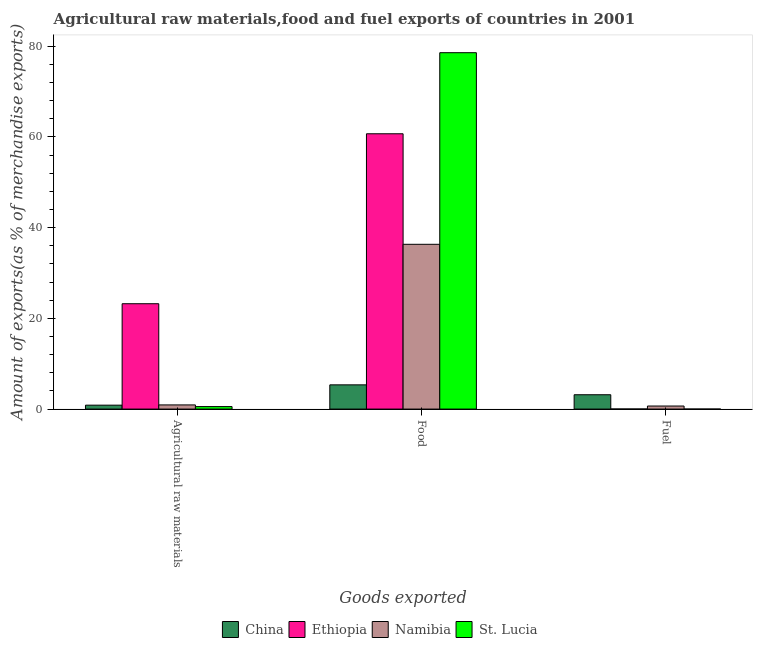How many different coloured bars are there?
Keep it short and to the point. 4. How many groups of bars are there?
Give a very brief answer. 3. Are the number of bars per tick equal to the number of legend labels?
Ensure brevity in your answer.  Yes. What is the label of the 3rd group of bars from the left?
Your answer should be very brief. Fuel. What is the percentage of raw materials exports in Ethiopia?
Provide a short and direct response. 23.22. Across all countries, what is the maximum percentage of fuel exports?
Keep it short and to the point. 3.16. Across all countries, what is the minimum percentage of fuel exports?
Offer a terse response. 0. In which country was the percentage of food exports maximum?
Offer a very short reply. St. Lucia. In which country was the percentage of raw materials exports minimum?
Your response must be concise. St. Lucia. What is the total percentage of fuel exports in the graph?
Keep it short and to the point. 3.85. What is the difference between the percentage of raw materials exports in Namibia and that in St. Lucia?
Your answer should be compact. 0.37. What is the difference between the percentage of raw materials exports in Ethiopia and the percentage of food exports in China?
Your response must be concise. 17.88. What is the average percentage of fuel exports per country?
Provide a short and direct response. 0.96. What is the difference between the percentage of food exports and percentage of fuel exports in Namibia?
Ensure brevity in your answer.  35.64. What is the ratio of the percentage of fuel exports in China to that in Namibia?
Provide a short and direct response. 4.68. Is the percentage of raw materials exports in St. Lucia less than that in Namibia?
Provide a short and direct response. Yes. What is the difference between the highest and the second highest percentage of raw materials exports?
Provide a succinct answer. 22.3. What is the difference between the highest and the lowest percentage of food exports?
Offer a terse response. 73.21. In how many countries, is the percentage of raw materials exports greater than the average percentage of raw materials exports taken over all countries?
Make the answer very short. 1. Is the sum of the percentage of fuel exports in Ethiopia and St. Lucia greater than the maximum percentage of raw materials exports across all countries?
Your answer should be very brief. No. What does the 3rd bar from the left in Agricultural raw materials represents?
Ensure brevity in your answer.  Namibia. What does the 1st bar from the right in Fuel represents?
Offer a terse response. St. Lucia. Is it the case that in every country, the sum of the percentage of raw materials exports and percentage of food exports is greater than the percentage of fuel exports?
Your answer should be compact. Yes. How many bars are there?
Keep it short and to the point. 12. Are the values on the major ticks of Y-axis written in scientific E-notation?
Your answer should be compact. No. Does the graph contain grids?
Provide a succinct answer. No. Where does the legend appear in the graph?
Keep it short and to the point. Bottom center. What is the title of the graph?
Give a very brief answer. Agricultural raw materials,food and fuel exports of countries in 2001. Does "Nepal" appear as one of the legend labels in the graph?
Provide a short and direct response. No. What is the label or title of the X-axis?
Your answer should be compact. Goods exported. What is the label or title of the Y-axis?
Your answer should be very brief. Amount of exports(as % of merchandise exports). What is the Amount of exports(as % of merchandise exports) in China in Agricultural raw materials?
Offer a very short reply. 0.86. What is the Amount of exports(as % of merchandise exports) in Ethiopia in Agricultural raw materials?
Offer a very short reply. 23.22. What is the Amount of exports(as % of merchandise exports) in Namibia in Agricultural raw materials?
Your answer should be very brief. 0.92. What is the Amount of exports(as % of merchandise exports) of St. Lucia in Agricultural raw materials?
Your response must be concise. 0.55. What is the Amount of exports(as % of merchandise exports) in China in Food?
Your answer should be compact. 5.34. What is the Amount of exports(as % of merchandise exports) of Ethiopia in Food?
Keep it short and to the point. 60.68. What is the Amount of exports(as % of merchandise exports) of Namibia in Food?
Give a very brief answer. 36.32. What is the Amount of exports(as % of merchandise exports) in St. Lucia in Food?
Provide a short and direct response. 78.55. What is the Amount of exports(as % of merchandise exports) of China in Fuel?
Ensure brevity in your answer.  3.16. What is the Amount of exports(as % of merchandise exports) in Ethiopia in Fuel?
Provide a succinct answer. 0.01. What is the Amount of exports(as % of merchandise exports) of Namibia in Fuel?
Offer a terse response. 0.67. What is the Amount of exports(as % of merchandise exports) of St. Lucia in Fuel?
Make the answer very short. 0. Across all Goods exported, what is the maximum Amount of exports(as % of merchandise exports) of China?
Provide a short and direct response. 5.34. Across all Goods exported, what is the maximum Amount of exports(as % of merchandise exports) of Ethiopia?
Make the answer very short. 60.68. Across all Goods exported, what is the maximum Amount of exports(as % of merchandise exports) of Namibia?
Provide a succinct answer. 36.32. Across all Goods exported, what is the maximum Amount of exports(as % of merchandise exports) of St. Lucia?
Provide a succinct answer. 78.55. Across all Goods exported, what is the minimum Amount of exports(as % of merchandise exports) in China?
Make the answer very short. 0.86. Across all Goods exported, what is the minimum Amount of exports(as % of merchandise exports) of Ethiopia?
Your response must be concise. 0.01. Across all Goods exported, what is the minimum Amount of exports(as % of merchandise exports) of Namibia?
Offer a terse response. 0.67. Across all Goods exported, what is the minimum Amount of exports(as % of merchandise exports) in St. Lucia?
Offer a terse response. 0. What is the total Amount of exports(as % of merchandise exports) in China in the graph?
Keep it short and to the point. 9.36. What is the total Amount of exports(as % of merchandise exports) in Ethiopia in the graph?
Ensure brevity in your answer.  83.91. What is the total Amount of exports(as % of merchandise exports) of Namibia in the graph?
Your answer should be very brief. 37.91. What is the total Amount of exports(as % of merchandise exports) in St. Lucia in the graph?
Offer a very short reply. 79.1. What is the difference between the Amount of exports(as % of merchandise exports) in China in Agricultural raw materials and that in Food?
Your answer should be very brief. -4.48. What is the difference between the Amount of exports(as % of merchandise exports) in Ethiopia in Agricultural raw materials and that in Food?
Your answer should be compact. -37.46. What is the difference between the Amount of exports(as % of merchandise exports) of Namibia in Agricultural raw materials and that in Food?
Provide a succinct answer. -35.4. What is the difference between the Amount of exports(as % of merchandise exports) of St. Lucia in Agricultural raw materials and that in Food?
Provide a succinct answer. -78. What is the difference between the Amount of exports(as % of merchandise exports) of China in Agricultural raw materials and that in Fuel?
Make the answer very short. -2.29. What is the difference between the Amount of exports(as % of merchandise exports) of Ethiopia in Agricultural raw materials and that in Fuel?
Ensure brevity in your answer.  23.2. What is the difference between the Amount of exports(as % of merchandise exports) in Namibia in Agricultural raw materials and that in Fuel?
Ensure brevity in your answer.  0.24. What is the difference between the Amount of exports(as % of merchandise exports) of St. Lucia in Agricultural raw materials and that in Fuel?
Give a very brief answer. 0.55. What is the difference between the Amount of exports(as % of merchandise exports) in China in Food and that in Fuel?
Offer a terse response. 2.18. What is the difference between the Amount of exports(as % of merchandise exports) of Ethiopia in Food and that in Fuel?
Provide a succinct answer. 60.67. What is the difference between the Amount of exports(as % of merchandise exports) of Namibia in Food and that in Fuel?
Your answer should be very brief. 35.64. What is the difference between the Amount of exports(as % of merchandise exports) in St. Lucia in Food and that in Fuel?
Offer a very short reply. 78.55. What is the difference between the Amount of exports(as % of merchandise exports) in China in Agricultural raw materials and the Amount of exports(as % of merchandise exports) in Ethiopia in Food?
Your response must be concise. -59.82. What is the difference between the Amount of exports(as % of merchandise exports) in China in Agricultural raw materials and the Amount of exports(as % of merchandise exports) in Namibia in Food?
Your response must be concise. -35.45. What is the difference between the Amount of exports(as % of merchandise exports) in China in Agricultural raw materials and the Amount of exports(as % of merchandise exports) in St. Lucia in Food?
Provide a short and direct response. -77.69. What is the difference between the Amount of exports(as % of merchandise exports) of Ethiopia in Agricultural raw materials and the Amount of exports(as % of merchandise exports) of Namibia in Food?
Ensure brevity in your answer.  -13.1. What is the difference between the Amount of exports(as % of merchandise exports) of Ethiopia in Agricultural raw materials and the Amount of exports(as % of merchandise exports) of St. Lucia in Food?
Give a very brief answer. -55.33. What is the difference between the Amount of exports(as % of merchandise exports) in Namibia in Agricultural raw materials and the Amount of exports(as % of merchandise exports) in St. Lucia in Food?
Your response must be concise. -77.63. What is the difference between the Amount of exports(as % of merchandise exports) of China in Agricultural raw materials and the Amount of exports(as % of merchandise exports) of Ethiopia in Fuel?
Ensure brevity in your answer.  0.85. What is the difference between the Amount of exports(as % of merchandise exports) in China in Agricultural raw materials and the Amount of exports(as % of merchandise exports) in Namibia in Fuel?
Make the answer very short. 0.19. What is the difference between the Amount of exports(as % of merchandise exports) of China in Agricultural raw materials and the Amount of exports(as % of merchandise exports) of St. Lucia in Fuel?
Provide a short and direct response. 0.86. What is the difference between the Amount of exports(as % of merchandise exports) in Ethiopia in Agricultural raw materials and the Amount of exports(as % of merchandise exports) in Namibia in Fuel?
Make the answer very short. 22.54. What is the difference between the Amount of exports(as % of merchandise exports) of Ethiopia in Agricultural raw materials and the Amount of exports(as % of merchandise exports) of St. Lucia in Fuel?
Provide a succinct answer. 23.22. What is the difference between the Amount of exports(as % of merchandise exports) of Namibia in Agricultural raw materials and the Amount of exports(as % of merchandise exports) of St. Lucia in Fuel?
Make the answer very short. 0.92. What is the difference between the Amount of exports(as % of merchandise exports) of China in Food and the Amount of exports(as % of merchandise exports) of Ethiopia in Fuel?
Make the answer very short. 5.33. What is the difference between the Amount of exports(as % of merchandise exports) of China in Food and the Amount of exports(as % of merchandise exports) of Namibia in Fuel?
Offer a terse response. 4.67. What is the difference between the Amount of exports(as % of merchandise exports) of China in Food and the Amount of exports(as % of merchandise exports) of St. Lucia in Fuel?
Offer a very short reply. 5.34. What is the difference between the Amount of exports(as % of merchandise exports) of Ethiopia in Food and the Amount of exports(as % of merchandise exports) of Namibia in Fuel?
Keep it short and to the point. 60.01. What is the difference between the Amount of exports(as % of merchandise exports) in Ethiopia in Food and the Amount of exports(as % of merchandise exports) in St. Lucia in Fuel?
Ensure brevity in your answer.  60.68. What is the difference between the Amount of exports(as % of merchandise exports) of Namibia in Food and the Amount of exports(as % of merchandise exports) of St. Lucia in Fuel?
Make the answer very short. 36.32. What is the average Amount of exports(as % of merchandise exports) in China per Goods exported?
Ensure brevity in your answer.  3.12. What is the average Amount of exports(as % of merchandise exports) of Ethiopia per Goods exported?
Your answer should be compact. 27.97. What is the average Amount of exports(as % of merchandise exports) in Namibia per Goods exported?
Provide a succinct answer. 12.64. What is the average Amount of exports(as % of merchandise exports) of St. Lucia per Goods exported?
Give a very brief answer. 26.37. What is the difference between the Amount of exports(as % of merchandise exports) of China and Amount of exports(as % of merchandise exports) of Ethiopia in Agricultural raw materials?
Your answer should be very brief. -22.36. What is the difference between the Amount of exports(as % of merchandise exports) in China and Amount of exports(as % of merchandise exports) in Namibia in Agricultural raw materials?
Ensure brevity in your answer.  -0.05. What is the difference between the Amount of exports(as % of merchandise exports) in China and Amount of exports(as % of merchandise exports) in St. Lucia in Agricultural raw materials?
Provide a short and direct response. 0.32. What is the difference between the Amount of exports(as % of merchandise exports) of Ethiopia and Amount of exports(as % of merchandise exports) of Namibia in Agricultural raw materials?
Your response must be concise. 22.3. What is the difference between the Amount of exports(as % of merchandise exports) in Ethiopia and Amount of exports(as % of merchandise exports) in St. Lucia in Agricultural raw materials?
Provide a short and direct response. 22.67. What is the difference between the Amount of exports(as % of merchandise exports) of Namibia and Amount of exports(as % of merchandise exports) of St. Lucia in Agricultural raw materials?
Keep it short and to the point. 0.37. What is the difference between the Amount of exports(as % of merchandise exports) of China and Amount of exports(as % of merchandise exports) of Ethiopia in Food?
Your response must be concise. -55.34. What is the difference between the Amount of exports(as % of merchandise exports) in China and Amount of exports(as % of merchandise exports) in Namibia in Food?
Your answer should be compact. -30.98. What is the difference between the Amount of exports(as % of merchandise exports) of China and Amount of exports(as % of merchandise exports) of St. Lucia in Food?
Give a very brief answer. -73.21. What is the difference between the Amount of exports(as % of merchandise exports) of Ethiopia and Amount of exports(as % of merchandise exports) of Namibia in Food?
Make the answer very short. 24.36. What is the difference between the Amount of exports(as % of merchandise exports) of Ethiopia and Amount of exports(as % of merchandise exports) of St. Lucia in Food?
Offer a very short reply. -17.87. What is the difference between the Amount of exports(as % of merchandise exports) in Namibia and Amount of exports(as % of merchandise exports) in St. Lucia in Food?
Offer a terse response. -42.23. What is the difference between the Amount of exports(as % of merchandise exports) in China and Amount of exports(as % of merchandise exports) in Ethiopia in Fuel?
Make the answer very short. 3.14. What is the difference between the Amount of exports(as % of merchandise exports) in China and Amount of exports(as % of merchandise exports) in Namibia in Fuel?
Your answer should be very brief. 2.48. What is the difference between the Amount of exports(as % of merchandise exports) of China and Amount of exports(as % of merchandise exports) of St. Lucia in Fuel?
Give a very brief answer. 3.16. What is the difference between the Amount of exports(as % of merchandise exports) in Ethiopia and Amount of exports(as % of merchandise exports) in Namibia in Fuel?
Offer a terse response. -0.66. What is the difference between the Amount of exports(as % of merchandise exports) of Ethiopia and Amount of exports(as % of merchandise exports) of St. Lucia in Fuel?
Your answer should be very brief. 0.01. What is the difference between the Amount of exports(as % of merchandise exports) of Namibia and Amount of exports(as % of merchandise exports) of St. Lucia in Fuel?
Ensure brevity in your answer.  0.67. What is the ratio of the Amount of exports(as % of merchandise exports) of China in Agricultural raw materials to that in Food?
Ensure brevity in your answer.  0.16. What is the ratio of the Amount of exports(as % of merchandise exports) of Ethiopia in Agricultural raw materials to that in Food?
Your answer should be compact. 0.38. What is the ratio of the Amount of exports(as % of merchandise exports) of Namibia in Agricultural raw materials to that in Food?
Your answer should be compact. 0.03. What is the ratio of the Amount of exports(as % of merchandise exports) of St. Lucia in Agricultural raw materials to that in Food?
Provide a short and direct response. 0.01. What is the ratio of the Amount of exports(as % of merchandise exports) of China in Agricultural raw materials to that in Fuel?
Keep it short and to the point. 0.27. What is the ratio of the Amount of exports(as % of merchandise exports) in Ethiopia in Agricultural raw materials to that in Fuel?
Provide a short and direct response. 1585.14. What is the ratio of the Amount of exports(as % of merchandise exports) of Namibia in Agricultural raw materials to that in Fuel?
Your answer should be compact. 1.36. What is the ratio of the Amount of exports(as % of merchandise exports) of St. Lucia in Agricultural raw materials to that in Fuel?
Your answer should be very brief. 949.64. What is the ratio of the Amount of exports(as % of merchandise exports) of China in Food to that in Fuel?
Offer a very short reply. 1.69. What is the ratio of the Amount of exports(as % of merchandise exports) of Ethiopia in Food to that in Fuel?
Make the answer very short. 4142.63. What is the ratio of the Amount of exports(as % of merchandise exports) in Namibia in Food to that in Fuel?
Your response must be concise. 53.84. What is the ratio of the Amount of exports(as % of merchandise exports) in St. Lucia in Food to that in Fuel?
Offer a very short reply. 1.36e+05. What is the difference between the highest and the second highest Amount of exports(as % of merchandise exports) of China?
Make the answer very short. 2.18. What is the difference between the highest and the second highest Amount of exports(as % of merchandise exports) in Ethiopia?
Provide a succinct answer. 37.46. What is the difference between the highest and the second highest Amount of exports(as % of merchandise exports) of Namibia?
Keep it short and to the point. 35.4. What is the difference between the highest and the second highest Amount of exports(as % of merchandise exports) in St. Lucia?
Provide a succinct answer. 78. What is the difference between the highest and the lowest Amount of exports(as % of merchandise exports) in China?
Your answer should be very brief. 4.48. What is the difference between the highest and the lowest Amount of exports(as % of merchandise exports) of Ethiopia?
Your answer should be compact. 60.67. What is the difference between the highest and the lowest Amount of exports(as % of merchandise exports) of Namibia?
Provide a succinct answer. 35.64. What is the difference between the highest and the lowest Amount of exports(as % of merchandise exports) in St. Lucia?
Your answer should be compact. 78.55. 